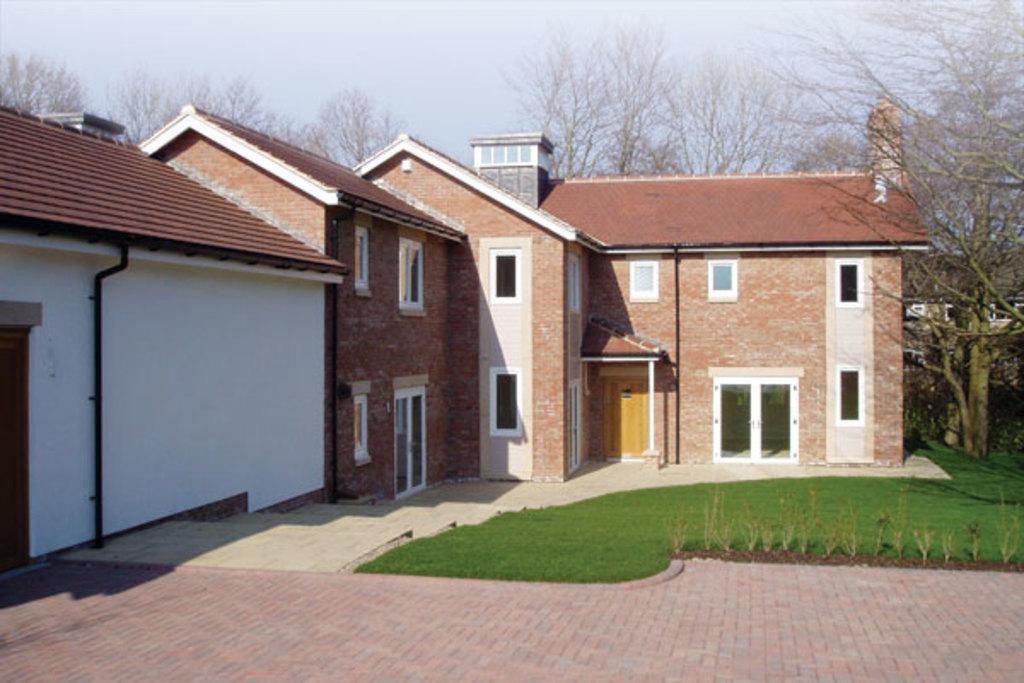How would you summarize this image in a sentence or two? In the picture we can see some houses with windows, doors and glasses to it and near the houses we can see a grass surface and a part of the path with tiles and in the background we can see some trees and the sky. 